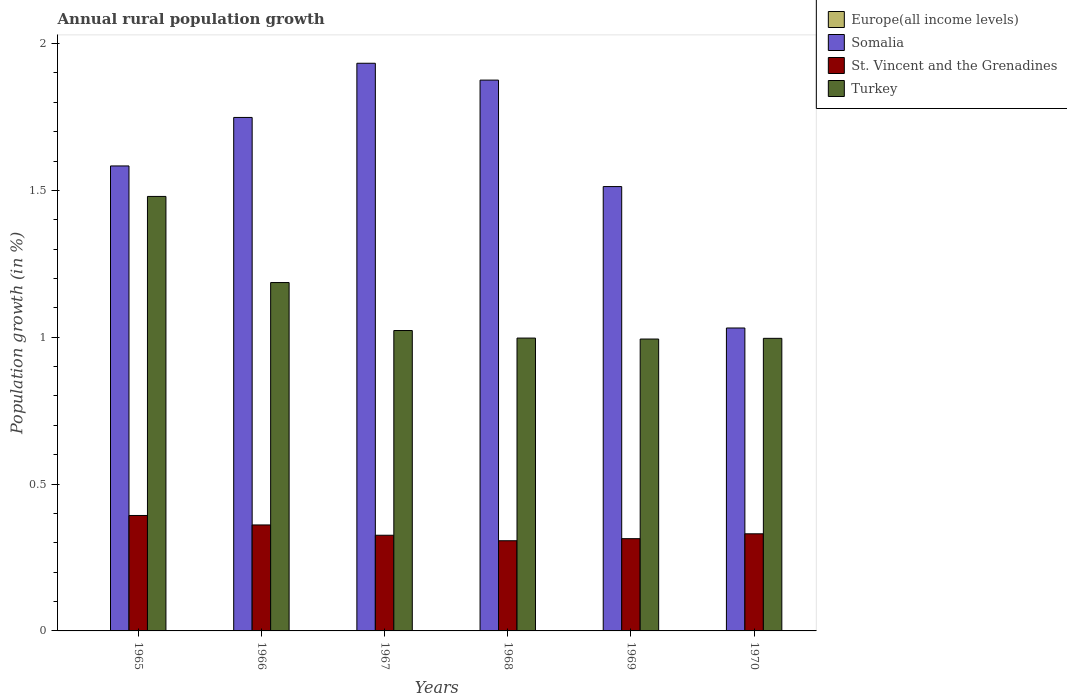How many different coloured bars are there?
Your response must be concise. 3. How many bars are there on the 3rd tick from the right?
Keep it short and to the point. 3. What is the label of the 4th group of bars from the left?
Make the answer very short. 1968. What is the percentage of rural population growth in Somalia in 1970?
Provide a short and direct response. 1.03. Across all years, what is the maximum percentage of rural population growth in Turkey?
Provide a short and direct response. 1.48. Across all years, what is the minimum percentage of rural population growth in Europe(all income levels)?
Give a very brief answer. 0. In which year was the percentage of rural population growth in St. Vincent and the Grenadines maximum?
Give a very brief answer. 1965. What is the total percentage of rural population growth in Europe(all income levels) in the graph?
Your answer should be very brief. 0. What is the difference between the percentage of rural population growth in Turkey in 1966 and that in 1967?
Ensure brevity in your answer.  0.16. What is the difference between the percentage of rural population growth in Europe(all income levels) in 1965 and the percentage of rural population growth in Somalia in 1970?
Offer a terse response. -1.03. What is the average percentage of rural population growth in St. Vincent and the Grenadines per year?
Offer a very short reply. 0.34. In the year 1969, what is the difference between the percentage of rural population growth in St. Vincent and the Grenadines and percentage of rural population growth in Turkey?
Give a very brief answer. -0.68. What is the ratio of the percentage of rural population growth in St. Vincent and the Grenadines in 1965 to that in 1968?
Give a very brief answer. 1.28. Is the percentage of rural population growth in Turkey in 1967 less than that in 1968?
Your response must be concise. No. Is the difference between the percentage of rural population growth in St. Vincent and the Grenadines in 1967 and 1969 greater than the difference between the percentage of rural population growth in Turkey in 1967 and 1969?
Your response must be concise. No. What is the difference between the highest and the second highest percentage of rural population growth in St. Vincent and the Grenadines?
Your answer should be very brief. 0.03. What is the difference between the highest and the lowest percentage of rural population growth in St. Vincent and the Grenadines?
Provide a succinct answer. 0.09. Is it the case that in every year, the sum of the percentage of rural population growth in St. Vincent and the Grenadines and percentage of rural population growth in Europe(all income levels) is greater than the sum of percentage of rural population growth in Turkey and percentage of rural population growth in Somalia?
Provide a short and direct response. No. Is it the case that in every year, the sum of the percentage of rural population growth in Somalia and percentage of rural population growth in St. Vincent and the Grenadines is greater than the percentage of rural population growth in Europe(all income levels)?
Your answer should be compact. Yes. How many years are there in the graph?
Give a very brief answer. 6. Does the graph contain any zero values?
Give a very brief answer. Yes. Where does the legend appear in the graph?
Keep it short and to the point. Top right. How are the legend labels stacked?
Your answer should be very brief. Vertical. What is the title of the graph?
Keep it short and to the point. Annual rural population growth. What is the label or title of the Y-axis?
Offer a terse response. Population growth (in %). What is the Population growth (in %) of Somalia in 1965?
Keep it short and to the point. 1.58. What is the Population growth (in %) of St. Vincent and the Grenadines in 1965?
Ensure brevity in your answer.  0.39. What is the Population growth (in %) of Turkey in 1965?
Your answer should be compact. 1.48. What is the Population growth (in %) of Europe(all income levels) in 1966?
Provide a short and direct response. 0. What is the Population growth (in %) in Somalia in 1966?
Your answer should be very brief. 1.75. What is the Population growth (in %) in St. Vincent and the Grenadines in 1966?
Your answer should be compact. 0.36. What is the Population growth (in %) in Turkey in 1966?
Your answer should be compact. 1.19. What is the Population growth (in %) of Somalia in 1967?
Give a very brief answer. 1.93. What is the Population growth (in %) in St. Vincent and the Grenadines in 1967?
Your answer should be compact. 0.33. What is the Population growth (in %) of Turkey in 1967?
Provide a short and direct response. 1.02. What is the Population growth (in %) of Somalia in 1968?
Your answer should be compact. 1.88. What is the Population growth (in %) of St. Vincent and the Grenadines in 1968?
Give a very brief answer. 0.31. What is the Population growth (in %) of Turkey in 1968?
Give a very brief answer. 1. What is the Population growth (in %) of Somalia in 1969?
Make the answer very short. 1.51. What is the Population growth (in %) of St. Vincent and the Grenadines in 1969?
Provide a succinct answer. 0.31. What is the Population growth (in %) of Turkey in 1969?
Keep it short and to the point. 0.99. What is the Population growth (in %) of Somalia in 1970?
Your answer should be very brief. 1.03. What is the Population growth (in %) in St. Vincent and the Grenadines in 1970?
Your answer should be compact. 0.33. What is the Population growth (in %) in Turkey in 1970?
Offer a terse response. 1. Across all years, what is the maximum Population growth (in %) in Somalia?
Provide a succinct answer. 1.93. Across all years, what is the maximum Population growth (in %) in St. Vincent and the Grenadines?
Offer a terse response. 0.39. Across all years, what is the maximum Population growth (in %) of Turkey?
Your answer should be compact. 1.48. Across all years, what is the minimum Population growth (in %) in Somalia?
Make the answer very short. 1.03. Across all years, what is the minimum Population growth (in %) of St. Vincent and the Grenadines?
Provide a succinct answer. 0.31. Across all years, what is the minimum Population growth (in %) of Turkey?
Keep it short and to the point. 0.99. What is the total Population growth (in %) in Somalia in the graph?
Your answer should be very brief. 9.68. What is the total Population growth (in %) in St. Vincent and the Grenadines in the graph?
Offer a very short reply. 2.03. What is the total Population growth (in %) in Turkey in the graph?
Keep it short and to the point. 6.68. What is the difference between the Population growth (in %) in Somalia in 1965 and that in 1966?
Give a very brief answer. -0.17. What is the difference between the Population growth (in %) of St. Vincent and the Grenadines in 1965 and that in 1966?
Offer a terse response. 0.03. What is the difference between the Population growth (in %) in Turkey in 1965 and that in 1966?
Offer a very short reply. 0.29. What is the difference between the Population growth (in %) of Somalia in 1965 and that in 1967?
Make the answer very short. -0.35. What is the difference between the Population growth (in %) of St. Vincent and the Grenadines in 1965 and that in 1967?
Give a very brief answer. 0.07. What is the difference between the Population growth (in %) of Turkey in 1965 and that in 1967?
Your answer should be compact. 0.46. What is the difference between the Population growth (in %) in Somalia in 1965 and that in 1968?
Make the answer very short. -0.29. What is the difference between the Population growth (in %) in St. Vincent and the Grenadines in 1965 and that in 1968?
Provide a succinct answer. 0.09. What is the difference between the Population growth (in %) of Turkey in 1965 and that in 1968?
Give a very brief answer. 0.48. What is the difference between the Population growth (in %) in Somalia in 1965 and that in 1969?
Your answer should be very brief. 0.07. What is the difference between the Population growth (in %) of St. Vincent and the Grenadines in 1965 and that in 1969?
Your answer should be compact. 0.08. What is the difference between the Population growth (in %) in Turkey in 1965 and that in 1969?
Offer a terse response. 0.49. What is the difference between the Population growth (in %) in Somalia in 1965 and that in 1970?
Your answer should be compact. 0.55. What is the difference between the Population growth (in %) of St. Vincent and the Grenadines in 1965 and that in 1970?
Make the answer very short. 0.06. What is the difference between the Population growth (in %) of Turkey in 1965 and that in 1970?
Keep it short and to the point. 0.48. What is the difference between the Population growth (in %) of Somalia in 1966 and that in 1967?
Offer a terse response. -0.18. What is the difference between the Population growth (in %) of St. Vincent and the Grenadines in 1966 and that in 1967?
Give a very brief answer. 0.04. What is the difference between the Population growth (in %) of Turkey in 1966 and that in 1967?
Provide a short and direct response. 0.16. What is the difference between the Population growth (in %) in Somalia in 1966 and that in 1968?
Keep it short and to the point. -0.13. What is the difference between the Population growth (in %) of St. Vincent and the Grenadines in 1966 and that in 1968?
Give a very brief answer. 0.05. What is the difference between the Population growth (in %) in Turkey in 1966 and that in 1968?
Ensure brevity in your answer.  0.19. What is the difference between the Population growth (in %) of Somalia in 1966 and that in 1969?
Provide a succinct answer. 0.24. What is the difference between the Population growth (in %) in St. Vincent and the Grenadines in 1966 and that in 1969?
Your answer should be very brief. 0.05. What is the difference between the Population growth (in %) in Turkey in 1966 and that in 1969?
Provide a short and direct response. 0.19. What is the difference between the Population growth (in %) of Somalia in 1966 and that in 1970?
Ensure brevity in your answer.  0.72. What is the difference between the Population growth (in %) of St. Vincent and the Grenadines in 1966 and that in 1970?
Ensure brevity in your answer.  0.03. What is the difference between the Population growth (in %) in Turkey in 1966 and that in 1970?
Give a very brief answer. 0.19. What is the difference between the Population growth (in %) of Somalia in 1967 and that in 1968?
Make the answer very short. 0.06. What is the difference between the Population growth (in %) in St. Vincent and the Grenadines in 1967 and that in 1968?
Offer a terse response. 0.02. What is the difference between the Population growth (in %) in Turkey in 1967 and that in 1968?
Your response must be concise. 0.03. What is the difference between the Population growth (in %) of Somalia in 1967 and that in 1969?
Keep it short and to the point. 0.42. What is the difference between the Population growth (in %) in St. Vincent and the Grenadines in 1967 and that in 1969?
Your answer should be very brief. 0.01. What is the difference between the Population growth (in %) in Turkey in 1967 and that in 1969?
Your answer should be compact. 0.03. What is the difference between the Population growth (in %) of Somalia in 1967 and that in 1970?
Offer a very short reply. 0.9. What is the difference between the Population growth (in %) of St. Vincent and the Grenadines in 1967 and that in 1970?
Offer a very short reply. -0. What is the difference between the Population growth (in %) of Turkey in 1967 and that in 1970?
Offer a terse response. 0.03. What is the difference between the Population growth (in %) of Somalia in 1968 and that in 1969?
Give a very brief answer. 0.36. What is the difference between the Population growth (in %) of St. Vincent and the Grenadines in 1968 and that in 1969?
Your response must be concise. -0.01. What is the difference between the Population growth (in %) of Turkey in 1968 and that in 1969?
Your response must be concise. 0. What is the difference between the Population growth (in %) in Somalia in 1968 and that in 1970?
Your answer should be very brief. 0.84. What is the difference between the Population growth (in %) in St. Vincent and the Grenadines in 1968 and that in 1970?
Provide a succinct answer. -0.02. What is the difference between the Population growth (in %) of Turkey in 1968 and that in 1970?
Keep it short and to the point. 0. What is the difference between the Population growth (in %) of Somalia in 1969 and that in 1970?
Provide a short and direct response. 0.48. What is the difference between the Population growth (in %) in St. Vincent and the Grenadines in 1969 and that in 1970?
Keep it short and to the point. -0.02. What is the difference between the Population growth (in %) of Turkey in 1969 and that in 1970?
Offer a terse response. -0. What is the difference between the Population growth (in %) in Somalia in 1965 and the Population growth (in %) in St. Vincent and the Grenadines in 1966?
Give a very brief answer. 1.22. What is the difference between the Population growth (in %) in Somalia in 1965 and the Population growth (in %) in Turkey in 1966?
Your response must be concise. 0.4. What is the difference between the Population growth (in %) in St. Vincent and the Grenadines in 1965 and the Population growth (in %) in Turkey in 1966?
Give a very brief answer. -0.79. What is the difference between the Population growth (in %) in Somalia in 1965 and the Population growth (in %) in St. Vincent and the Grenadines in 1967?
Make the answer very short. 1.26. What is the difference between the Population growth (in %) in Somalia in 1965 and the Population growth (in %) in Turkey in 1967?
Give a very brief answer. 0.56. What is the difference between the Population growth (in %) in St. Vincent and the Grenadines in 1965 and the Population growth (in %) in Turkey in 1967?
Provide a short and direct response. -0.63. What is the difference between the Population growth (in %) in Somalia in 1965 and the Population growth (in %) in St. Vincent and the Grenadines in 1968?
Ensure brevity in your answer.  1.28. What is the difference between the Population growth (in %) of Somalia in 1965 and the Population growth (in %) of Turkey in 1968?
Offer a very short reply. 0.59. What is the difference between the Population growth (in %) of St. Vincent and the Grenadines in 1965 and the Population growth (in %) of Turkey in 1968?
Offer a terse response. -0.6. What is the difference between the Population growth (in %) of Somalia in 1965 and the Population growth (in %) of St. Vincent and the Grenadines in 1969?
Make the answer very short. 1.27. What is the difference between the Population growth (in %) of Somalia in 1965 and the Population growth (in %) of Turkey in 1969?
Offer a terse response. 0.59. What is the difference between the Population growth (in %) in St. Vincent and the Grenadines in 1965 and the Population growth (in %) in Turkey in 1969?
Provide a short and direct response. -0.6. What is the difference between the Population growth (in %) in Somalia in 1965 and the Population growth (in %) in St. Vincent and the Grenadines in 1970?
Your answer should be very brief. 1.25. What is the difference between the Population growth (in %) of Somalia in 1965 and the Population growth (in %) of Turkey in 1970?
Provide a short and direct response. 0.59. What is the difference between the Population growth (in %) of St. Vincent and the Grenadines in 1965 and the Population growth (in %) of Turkey in 1970?
Offer a very short reply. -0.6. What is the difference between the Population growth (in %) in Somalia in 1966 and the Population growth (in %) in St. Vincent and the Grenadines in 1967?
Give a very brief answer. 1.42. What is the difference between the Population growth (in %) of Somalia in 1966 and the Population growth (in %) of Turkey in 1967?
Make the answer very short. 0.73. What is the difference between the Population growth (in %) of St. Vincent and the Grenadines in 1966 and the Population growth (in %) of Turkey in 1967?
Keep it short and to the point. -0.66. What is the difference between the Population growth (in %) of Somalia in 1966 and the Population growth (in %) of St. Vincent and the Grenadines in 1968?
Ensure brevity in your answer.  1.44. What is the difference between the Population growth (in %) in Somalia in 1966 and the Population growth (in %) in Turkey in 1968?
Keep it short and to the point. 0.75. What is the difference between the Population growth (in %) in St. Vincent and the Grenadines in 1966 and the Population growth (in %) in Turkey in 1968?
Offer a terse response. -0.64. What is the difference between the Population growth (in %) in Somalia in 1966 and the Population growth (in %) in St. Vincent and the Grenadines in 1969?
Offer a terse response. 1.43. What is the difference between the Population growth (in %) of Somalia in 1966 and the Population growth (in %) of Turkey in 1969?
Provide a short and direct response. 0.75. What is the difference between the Population growth (in %) in St. Vincent and the Grenadines in 1966 and the Population growth (in %) in Turkey in 1969?
Provide a succinct answer. -0.63. What is the difference between the Population growth (in %) in Somalia in 1966 and the Population growth (in %) in St. Vincent and the Grenadines in 1970?
Offer a terse response. 1.42. What is the difference between the Population growth (in %) in Somalia in 1966 and the Population growth (in %) in Turkey in 1970?
Ensure brevity in your answer.  0.75. What is the difference between the Population growth (in %) of St. Vincent and the Grenadines in 1966 and the Population growth (in %) of Turkey in 1970?
Keep it short and to the point. -0.64. What is the difference between the Population growth (in %) in Somalia in 1967 and the Population growth (in %) in St. Vincent and the Grenadines in 1968?
Ensure brevity in your answer.  1.63. What is the difference between the Population growth (in %) of Somalia in 1967 and the Population growth (in %) of Turkey in 1968?
Keep it short and to the point. 0.94. What is the difference between the Population growth (in %) in St. Vincent and the Grenadines in 1967 and the Population growth (in %) in Turkey in 1968?
Make the answer very short. -0.67. What is the difference between the Population growth (in %) in Somalia in 1967 and the Population growth (in %) in St. Vincent and the Grenadines in 1969?
Offer a terse response. 1.62. What is the difference between the Population growth (in %) in Somalia in 1967 and the Population growth (in %) in Turkey in 1969?
Provide a short and direct response. 0.94. What is the difference between the Population growth (in %) in St. Vincent and the Grenadines in 1967 and the Population growth (in %) in Turkey in 1969?
Provide a succinct answer. -0.67. What is the difference between the Population growth (in %) of Somalia in 1967 and the Population growth (in %) of St. Vincent and the Grenadines in 1970?
Give a very brief answer. 1.6. What is the difference between the Population growth (in %) in Somalia in 1967 and the Population growth (in %) in Turkey in 1970?
Offer a very short reply. 0.94. What is the difference between the Population growth (in %) of St. Vincent and the Grenadines in 1967 and the Population growth (in %) of Turkey in 1970?
Give a very brief answer. -0.67. What is the difference between the Population growth (in %) of Somalia in 1968 and the Population growth (in %) of St. Vincent and the Grenadines in 1969?
Provide a succinct answer. 1.56. What is the difference between the Population growth (in %) in Somalia in 1968 and the Population growth (in %) in Turkey in 1969?
Your answer should be very brief. 0.88. What is the difference between the Population growth (in %) in St. Vincent and the Grenadines in 1968 and the Population growth (in %) in Turkey in 1969?
Ensure brevity in your answer.  -0.69. What is the difference between the Population growth (in %) in Somalia in 1968 and the Population growth (in %) in St. Vincent and the Grenadines in 1970?
Offer a very short reply. 1.54. What is the difference between the Population growth (in %) of Somalia in 1968 and the Population growth (in %) of Turkey in 1970?
Your answer should be very brief. 0.88. What is the difference between the Population growth (in %) of St. Vincent and the Grenadines in 1968 and the Population growth (in %) of Turkey in 1970?
Your answer should be compact. -0.69. What is the difference between the Population growth (in %) of Somalia in 1969 and the Population growth (in %) of St. Vincent and the Grenadines in 1970?
Offer a very short reply. 1.18. What is the difference between the Population growth (in %) in Somalia in 1969 and the Population growth (in %) in Turkey in 1970?
Provide a short and direct response. 0.52. What is the difference between the Population growth (in %) in St. Vincent and the Grenadines in 1969 and the Population growth (in %) in Turkey in 1970?
Ensure brevity in your answer.  -0.68. What is the average Population growth (in %) in Somalia per year?
Your answer should be compact. 1.61. What is the average Population growth (in %) in St. Vincent and the Grenadines per year?
Provide a short and direct response. 0.34. What is the average Population growth (in %) of Turkey per year?
Give a very brief answer. 1.11. In the year 1965, what is the difference between the Population growth (in %) in Somalia and Population growth (in %) in St. Vincent and the Grenadines?
Your answer should be compact. 1.19. In the year 1965, what is the difference between the Population growth (in %) in Somalia and Population growth (in %) in Turkey?
Give a very brief answer. 0.1. In the year 1965, what is the difference between the Population growth (in %) in St. Vincent and the Grenadines and Population growth (in %) in Turkey?
Keep it short and to the point. -1.09. In the year 1966, what is the difference between the Population growth (in %) in Somalia and Population growth (in %) in St. Vincent and the Grenadines?
Provide a succinct answer. 1.39. In the year 1966, what is the difference between the Population growth (in %) of Somalia and Population growth (in %) of Turkey?
Your answer should be very brief. 0.56. In the year 1966, what is the difference between the Population growth (in %) of St. Vincent and the Grenadines and Population growth (in %) of Turkey?
Make the answer very short. -0.83. In the year 1967, what is the difference between the Population growth (in %) in Somalia and Population growth (in %) in St. Vincent and the Grenadines?
Your answer should be compact. 1.61. In the year 1967, what is the difference between the Population growth (in %) in Somalia and Population growth (in %) in Turkey?
Offer a terse response. 0.91. In the year 1967, what is the difference between the Population growth (in %) in St. Vincent and the Grenadines and Population growth (in %) in Turkey?
Provide a short and direct response. -0.7. In the year 1968, what is the difference between the Population growth (in %) of Somalia and Population growth (in %) of St. Vincent and the Grenadines?
Your answer should be compact. 1.57. In the year 1968, what is the difference between the Population growth (in %) in Somalia and Population growth (in %) in Turkey?
Provide a short and direct response. 0.88. In the year 1968, what is the difference between the Population growth (in %) in St. Vincent and the Grenadines and Population growth (in %) in Turkey?
Give a very brief answer. -0.69. In the year 1969, what is the difference between the Population growth (in %) in Somalia and Population growth (in %) in St. Vincent and the Grenadines?
Give a very brief answer. 1.2. In the year 1969, what is the difference between the Population growth (in %) in Somalia and Population growth (in %) in Turkey?
Provide a succinct answer. 0.52. In the year 1969, what is the difference between the Population growth (in %) in St. Vincent and the Grenadines and Population growth (in %) in Turkey?
Your answer should be very brief. -0.68. In the year 1970, what is the difference between the Population growth (in %) of Somalia and Population growth (in %) of St. Vincent and the Grenadines?
Your answer should be compact. 0.7. In the year 1970, what is the difference between the Population growth (in %) in Somalia and Population growth (in %) in Turkey?
Make the answer very short. 0.04. In the year 1970, what is the difference between the Population growth (in %) in St. Vincent and the Grenadines and Population growth (in %) in Turkey?
Keep it short and to the point. -0.67. What is the ratio of the Population growth (in %) of Somalia in 1965 to that in 1966?
Keep it short and to the point. 0.91. What is the ratio of the Population growth (in %) in St. Vincent and the Grenadines in 1965 to that in 1966?
Provide a succinct answer. 1.09. What is the ratio of the Population growth (in %) of Turkey in 1965 to that in 1966?
Provide a short and direct response. 1.25. What is the ratio of the Population growth (in %) of Somalia in 1965 to that in 1967?
Ensure brevity in your answer.  0.82. What is the ratio of the Population growth (in %) in St. Vincent and the Grenadines in 1965 to that in 1967?
Your answer should be very brief. 1.21. What is the ratio of the Population growth (in %) in Turkey in 1965 to that in 1967?
Give a very brief answer. 1.45. What is the ratio of the Population growth (in %) in Somalia in 1965 to that in 1968?
Provide a short and direct response. 0.84. What is the ratio of the Population growth (in %) of St. Vincent and the Grenadines in 1965 to that in 1968?
Make the answer very short. 1.28. What is the ratio of the Population growth (in %) of Turkey in 1965 to that in 1968?
Your answer should be compact. 1.48. What is the ratio of the Population growth (in %) of Somalia in 1965 to that in 1969?
Offer a terse response. 1.05. What is the ratio of the Population growth (in %) in St. Vincent and the Grenadines in 1965 to that in 1969?
Provide a short and direct response. 1.25. What is the ratio of the Population growth (in %) of Turkey in 1965 to that in 1969?
Your answer should be compact. 1.49. What is the ratio of the Population growth (in %) of Somalia in 1965 to that in 1970?
Ensure brevity in your answer.  1.53. What is the ratio of the Population growth (in %) in St. Vincent and the Grenadines in 1965 to that in 1970?
Your answer should be compact. 1.19. What is the ratio of the Population growth (in %) in Turkey in 1965 to that in 1970?
Give a very brief answer. 1.49. What is the ratio of the Population growth (in %) in Somalia in 1966 to that in 1967?
Ensure brevity in your answer.  0.9. What is the ratio of the Population growth (in %) of St. Vincent and the Grenadines in 1966 to that in 1967?
Provide a succinct answer. 1.11. What is the ratio of the Population growth (in %) in Turkey in 1966 to that in 1967?
Provide a succinct answer. 1.16. What is the ratio of the Population growth (in %) of Somalia in 1966 to that in 1968?
Your response must be concise. 0.93. What is the ratio of the Population growth (in %) in St. Vincent and the Grenadines in 1966 to that in 1968?
Provide a succinct answer. 1.18. What is the ratio of the Population growth (in %) of Turkey in 1966 to that in 1968?
Offer a very short reply. 1.19. What is the ratio of the Population growth (in %) in Somalia in 1966 to that in 1969?
Provide a succinct answer. 1.16. What is the ratio of the Population growth (in %) in St. Vincent and the Grenadines in 1966 to that in 1969?
Ensure brevity in your answer.  1.15. What is the ratio of the Population growth (in %) in Turkey in 1966 to that in 1969?
Make the answer very short. 1.19. What is the ratio of the Population growth (in %) of Somalia in 1966 to that in 1970?
Your answer should be compact. 1.7. What is the ratio of the Population growth (in %) of St. Vincent and the Grenadines in 1966 to that in 1970?
Give a very brief answer. 1.09. What is the ratio of the Population growth (in %) of Turkey in 1966 to that in 1970?
Ensure brevity in your answer.  1.19. What is the ratio of the Population growth (in %) of Somalia in 1967 to that in 1968?
Your response must be concise. 1.03. What is the ratio of the Population growth (in %) of St. Vincent and the Grenadines in 1967 to that in 1968?
Your answer should be compact. 1.06. What is the ratio of the Population growth (in %) of Turkey in 1967 to that in 1968?
Your answer should be compact. 1.03. What is the ratio of the Population growth (in %) of Somalia in 1967 to that in 1969?
Give a very brief answer. 1.28. What is the ratio of the Population growth (in %) in St. Vincent and the Grenadines in 1967 to that in 1969?
Your response must be concise. 1.04. What is the ratio of the Population growth (in %) in Turkey in 1967 to that in 1969?
Make the answer very short. 1.03. What is the ratio of the Population growth (in %) in Somalia in 1967 to that in 1970?
Your answer should be very brief. 1.87. What is the ratio of the Population growth (in %) in St. Vincent and the Grenadines in 1967 to that in 1970?
Make the answer very short. 0.99. What is the ratio of the Population growth (in %) in Turkey in 1967 to that in 1970?
Give a very brief answer. 1.03. What is the ratio of the Population growth (in %) in Somalia in 1968 to that in 1969?
Offer a terse response. 1.24. What is the ratio of the Population growth (in %) in St. Vincent and the Grenadines in 1968 to that in 1969?
Keep it short and to the point. 0.98. What is the ratio of the Population growth (in %) of Turkey in 1968 to that in 1969?
Your answer should be very brief. 1. What is the ratio of the Population growth (in %) of Somalia in 1968 to that in 1970?
Your answer should be very brief. 1.82. What is the ratio of the Population growth (in %) of St. Vincent and the Grenadines in 1968 to that in 1970?
Your answer should be compact. 0.93. What is the ratio of the Population growth (in %) of Turkey in 1968 to that in 1970?
Ensure brevity in your answer.  1. What is the ratio of the Population growth (in %) in Somalia in 1969 to that in 1970?
Your answer should be very brief. 1.47. What is the ratio of the Population growth (in %) of St. Vincent and the Grenadines in 1969 to that in 1970?
Make the answer very short. 0.95. What is the ratio of the Population growth (in %) in Turkey in 1969 to that in 1970?
Your answer should be compact. 1. What is the difference between the highest and the second highest Population growth (in %) of Somalia?
Make the answer very short. 0.06. What is the difference between the highest and the second highest Population growth (in %) in St. Vincent and the Grenadines?
Give a very brief answer. 0.03. What is the difference between the highest and the second highest Population growth (in %) of Turkey?
Offer a terse response. 0.29. What is the difference between the highest and the lowest Population growth (in %) in Somalia?
Provide a short and direct response. 0.9. What is the difference between the highest and the lowest Population growth (in %) of St. Vincent and the Grenadines?
Ensure brevity in your answer.  0.09. What is the difference between the highest and the lowest Population growth (in %) of Turkey?
Make the answer very short. 0.49. 